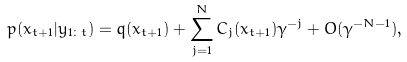Convert formula to latex. <formula><loc_0><loc_0><loc_500><loc_500>p ( x _ { t + 1 } | y _ { 1 \colon t } ) = q ( x _ { t + 1 } ) + \sum _ { j = 1 } ^ { N } { C _ { j } ( x _ { t + 1 } ) \gamma ^ { - j } } + O ( \gamma ^ { - N - 1 } ) ,</formula> 